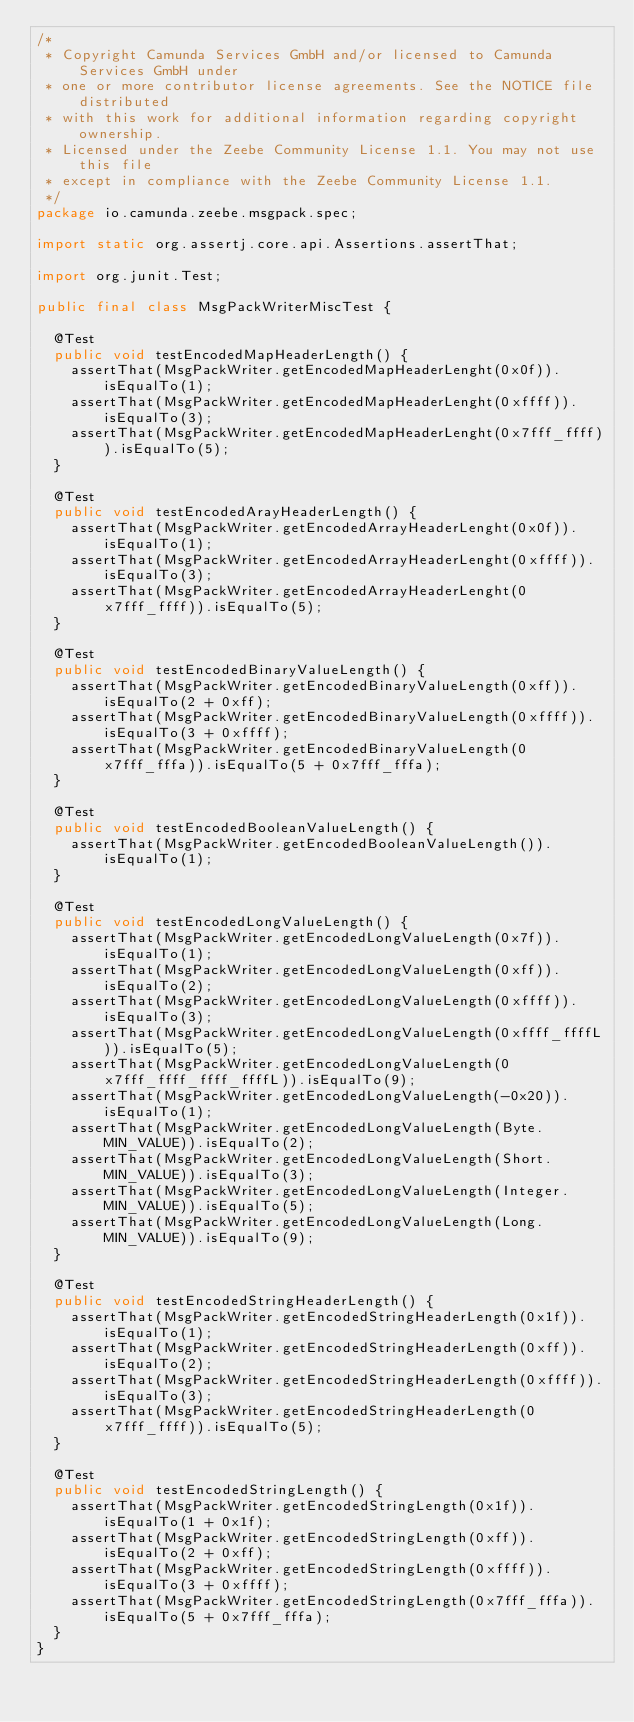<code> <loc_0><loc_0><loc_500><loc_500><_Java_>/*
 * Copyright Camunda Services GmbH and/or licensed to Camunda Services GmbH under
 * one or more contributor license agreements. See the NOTICE file distributed
 * with this work for additional information regarding copyright ownership.
 * Licensed under the Zeebe Community License 1.1. You may not use this file
 * except in compliance with the Zeebe Community License 1.1.
 */
package io.camunda.zeebe.msgpack.spec;

import static org.assertj.core.api.Assertions.assertThat;

import org.junit.Test;

public final class MsgPackWriterMiscTest {

  @Test
  public void testEncodedMapHeaderLength() {
    assertThat(MsgPackWriter.getEncodedMapHeaderLenght(0x0f)).isEqualTo(1);
    assertThat(MsgPackWriter.getEncodedMapHeaderLenght(0xffff)).isEqualTo(3);
    assertThat(MsgPackWriter.getEncodedMapHeaderLenght(0x7fff_ffff)).isEqualTo(5);
  }

  @Test
  public void testEncodedArayHeaderLength() {
    assertThat(MsgPackWriter.getEncodedArrayHeaderLenght(0x0f)).isEqualTo(1);
    assertThat(MsgPackWriter.getEncodedArrayHeaderLenght(0xffff)).isEqualTo(3);
    assertThat(MsgPackWriter.getEncodedArrayHeaderLenght(0x7fff_ffff)).isEqualTo(5);
  }

  @Test
  public void testEncodedBinaryValueLength() {
    assertThat(MsgPackWriter.getEncodedBinaryValueLength(0xff)).isEqualTo(2 + 0xff);
    assertThat(MsgPackWriter.getEncodedBinaryValueLength(0xffff)).isEqualTo(3 + 0xffff);
    assertThat(MsgPackWriter.getEncodedBinaryValueLength(0x7fff_fffa)).isEqualTo(5 + 0x7fff_fffa);
  }

  @Test
  public void testEncodedBooleanValueLength() {
    assertThat(MsgPackWriter.getEncodedBooleanValueLength()).isEqualTo(1);
  }

  @Test
  public void testEncodedLongValueLength() {
    assertThat(MsgPackWriter.getEncodedLongValueLength(0x7f)).isEqualTo(1);
    assertThat(MsgPackWriter.getEncodedLongValueLength(0xff)).isEqualTo(2);
    assertThat(MsgPackWriter.getEncodedLongValueLength(0xffff)).isEqualTo(3);
    assertThat(MsgPackWriter.getEncodedLongValueLength(0xffff_ffffL)).isEqualTo(5);
    assertThat(MsgPackWriter.getEncodedLongValueLength(0x7fff_ffff_ffff_ffffL)).isEqualTo(9);
    assertThat(MsgPackWriter.getEncodedLongValueLength(-0x20)).isEqualTo(1);
    assertThat(MsgPackWriter.getEncodedLongValueLength(Byte.MIN_VALUE)).isEqualTo(2);
    assertThat(MsgPackWriter.getEncodedLongValueLength(Short.MIN_VALUE)).isEqualTo(3);
    assertThat(MsgPackWriter.getEncodedLongValueLength(Integer.MIN_VALUE)).isEqualTo(5);
    assertThat(MsgPackWriter.getEncodedLongValueLength(Long.MIN_VALUE)).isEqualTo(9);
  }

  @Test
  public void testEncodedStringHeaderLength() {
    assertThat(MsgPackWriter.getEncodedStringHeaderLength(0x1f)).isEqualTo(1);
    assertThat(MsgPackWriter.getEncodedStringHeaderLength(0xff)).isEqualTo(2);
    assertThat(MsgPackWriter.getEncodedStringHeaderLength(0xffff)).isEqualTo(3);
    assertThat(MsgPackWriter.getEncodedStringHeaderLength(0x7fff_ffff)).isEqualTo(5);
  }

  @Test
  public void testEncodedStringLength() {
    assertThat(MsgPackWriter.getEncodedStringLength(0x1f)).isEqualTo(1 + 0x1f);
    assertThat(MsgPackWriter.getEncodedStringLength(0xff)).isEqualTo(2 + 0xff);
    assertThat(MsgPackWriter.getEncodedStringLength(0xffff)).isEqualTo(3 + 0xffff);
    assertThat(MsgPackWriter.getEncodedStringLength(0x7fff_fffa)).isEqualTo(5 + 0x7fff_fffa);
  }
}
</code> 